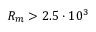<formula> <loc_0><loc_0><loc_500><loc_500>R _ { m } > 2 . 5 \cdot 1 0 ^ { 3 }</formula> 